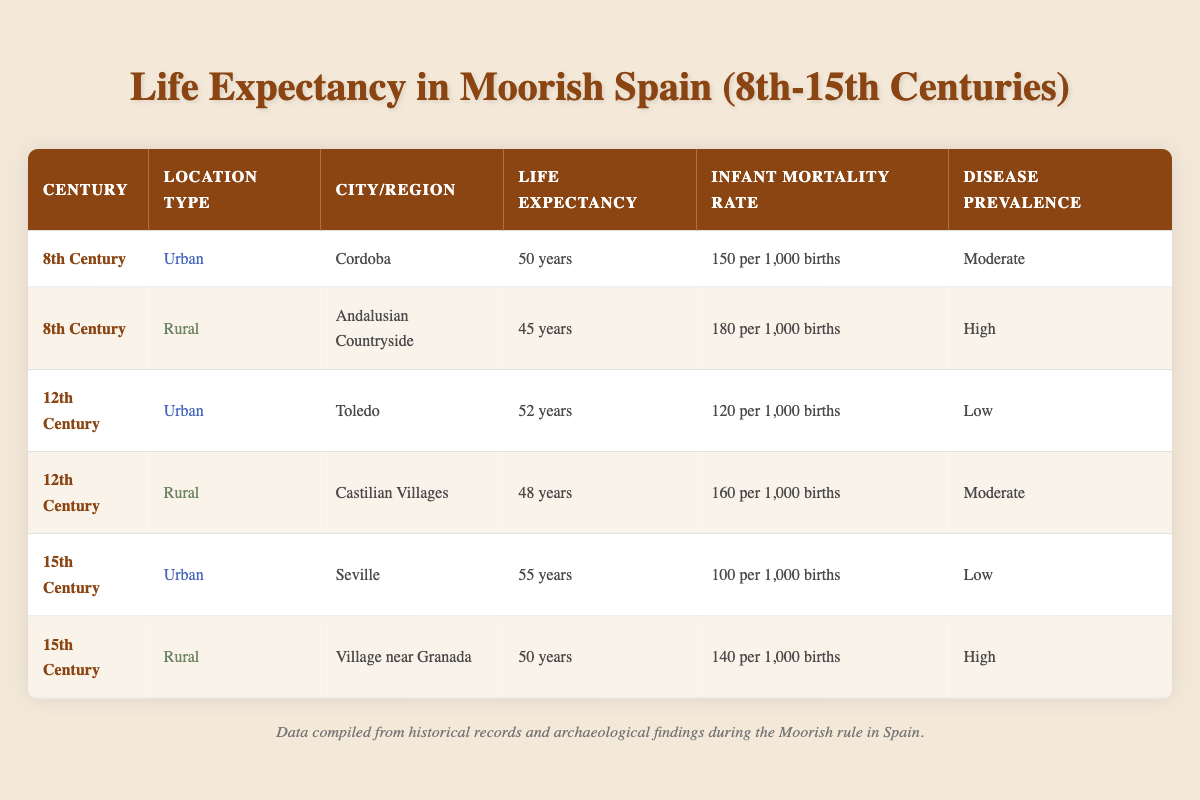What was the life expectancy in urban settings during the 15th century? According to the table, the life expectancy in urban settings during the 15th century was recorded for Seville, which was 55 years.
Answer: 55 years What was the infant mortality rate in the 8th century rural settings? The data shows that the infant mortality rate in the rural setting of the Andalusian Countryside during the 8th century was 180 per 1,000 births.
Answer: 180 per 1,000 births Which century had the highest life expectancy in urban areas? By reviewing the urban entries in the table, the life expectancy for Seville in the 15th century (55 years) is the highest, compared to Cordoba (50 years) in the 8th century and Toledo (52 years) in the 12th century.
Answer: 15th Century What is the difference in life expectancy between urban and rural settings in the 12th century? The urban life expectancy for Toledo in the 12th century is 52 years, while the rural life expectancy in Castilian Villages is 48 years. The difference is 52 - 48 = 4 years.
Answer: 4 years Was the disease prevalence lower in urban areas compared to rural areas in the 15th century? The urban area (Seville) had low disease prevalence while the rural area (Village near Granada) had high disease prevalence. This confirms that urban areas had a lower prevalence of disease compared to rural areas.
Answer: Yes What is the average life expectancy across all urban entries in the table? The urban life expectancies are 50 (Cordoba) + 52 (Toledo) + 55 (Seville) = 157 years. There are three urban entries, so the average is 157 / 3 = 52.33 years.
Answer: 52.33 years How does the infant mortality rate in the rural 15th century compare with the urban infant mortality rate in the same period? The rural setting (Village near Granada) had an infant mortality rate of 140 per 1,000 births, whereas the urban area (Seville) had a lower rate of 100 per 1,000 births. Thus, the rural mortality rate is higher by a difference of 140 - 100 = 40 per 1,000 births.
Answer: 40 per 1,000 births What health outcome was associated with the highest infant mortality rate in the table? The highest infant mortality rate recorded in the table was in the rural setting of the Andalusian Countryside during the 8th century, which was 180 per 1,000 births.
Answer: 180 per 1,000 births During which century did the rural areas show a decrease in life expectancy compared to urban settings? Analyzing the table, rural areas have consistently lower life expectancy than urban areas, particularly evident in the 12th century where urban Toledo (52 years) was higher than rural Castilian Villages (48 years).
Answer: 12th Century 